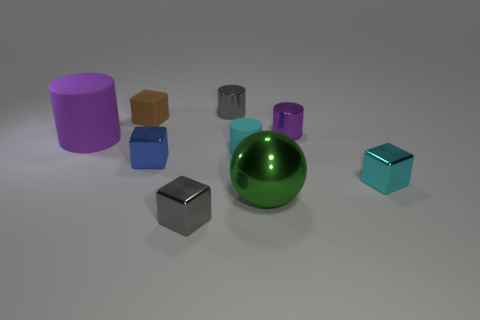There is a shiny object that is on the left side of the cube in front of the green metallic object; are there any tiny gray shiny blocks in front of it?
Ensure brevity in your answer.  Yes. The other metal object that is the same shape as the small purple object is what color?
Keep it short and to the point. Gray. How many green things are either small cubes or large rubber objects?
Keep it short and to the point. 0. What is the cylinder left of the metallic object on the left side of the gray block made of?
Provide a succinct answer. Rubber. Is the shape of the small purple thing the same as the tiny blue metallic thing?
Offer a terse response. No. There is a cylinder that is the same size as the green ball; what is its color?
Your answer should be very brief. Purple. Are there any large balls that have the same color as the small matte cylinder?
Give a very brief answer. No. Are any big green rubber balls visible?
Keep it short and to the point. No. Is the large object in front of the purple rubber cylinder made of the same material as the blue block?
Give a very brief answer. Yes. What number of cyan cubes have the same size as the brown thing?
Offer a terse response. 1. 